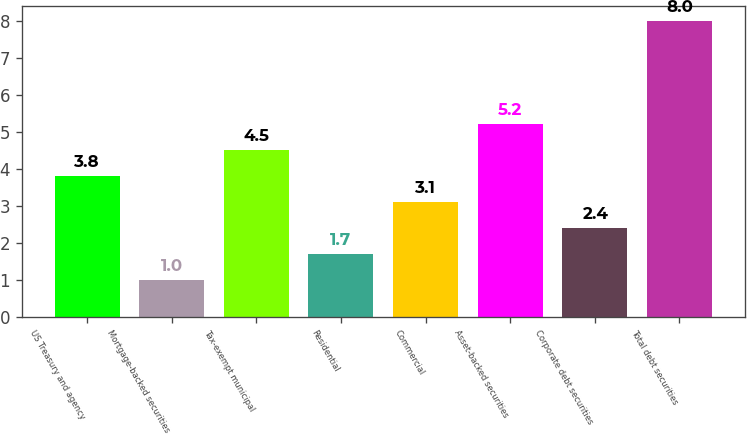Convert chart. <chart><loc_0><loc_0><loc_500><loc_500><bar_chart><fcel>US Treasury and agency<fcel>Mortgage-backed securities<fcel>Tax-exempt municipal<fcel>Residential<fcel>Commercial<fcel>Asset-backed securities<fcel>Corporate debt securities<fcel>Total debt securities<nl><fcel>3.8<fcel>1<fcel>4.5<fcel>1.7<fcel>3.1<fcel>5.2<fcel>2.4<fcel>8<nl></chart> 